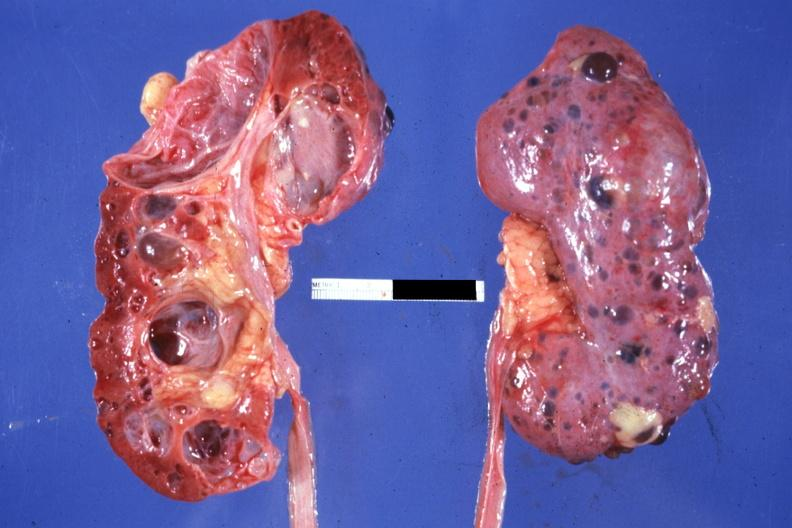how is nice photo one kidney opened the other from capsular surface cysts?
Answer the question using a single word or phrase. Many 